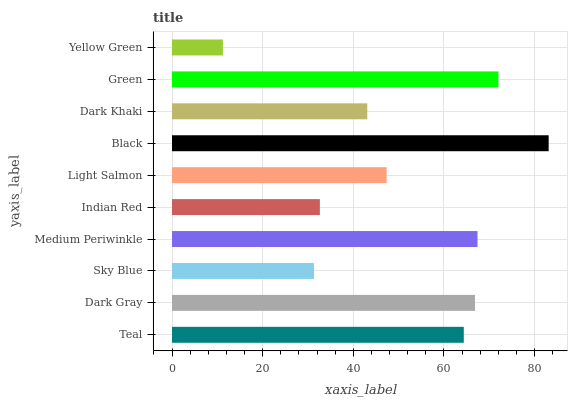Is Yellow Green the minimum?
Answer yes or no. Yes. Is Black the maximum?
Answer yes or no. Yes. Is Dark Gray the minimum?
Answer yes or no. No. Is Dark Gray the maximum?
Answer yes or no. No. Is Dark Gray greater than Teal?
Answer yes or no. Yes. Is Teal less than Dark Gray?
Answer yes or no. Yes. Is Teal greater than Dark Gray?
Answer yes or no. No. Is Dark Gray less than Teal?
Answer yes or no. No. Is Teal the high median?
Answer yes or no. Yes. Is Light Salmon the low median?
Answer yes or no. Yes. Is Sky Blue the high median?
Answer yes or no. No. Is Yellow Green the low median?
Answer yes or no. No. 